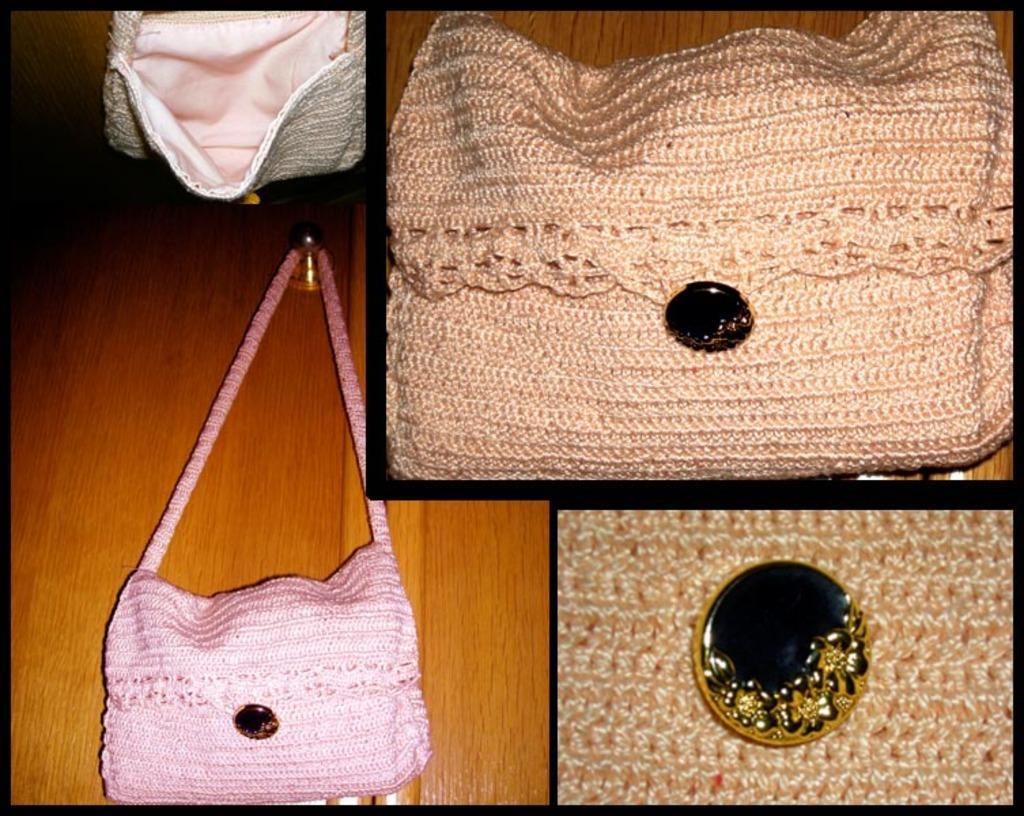Describe this image in one or two sentences. In the image we can see the picture is collage of three pictures in which there are bags which are kept on table and the bag over here is in pink colour and other bag is in peach colour and in between there is a golden and black colour dial. 